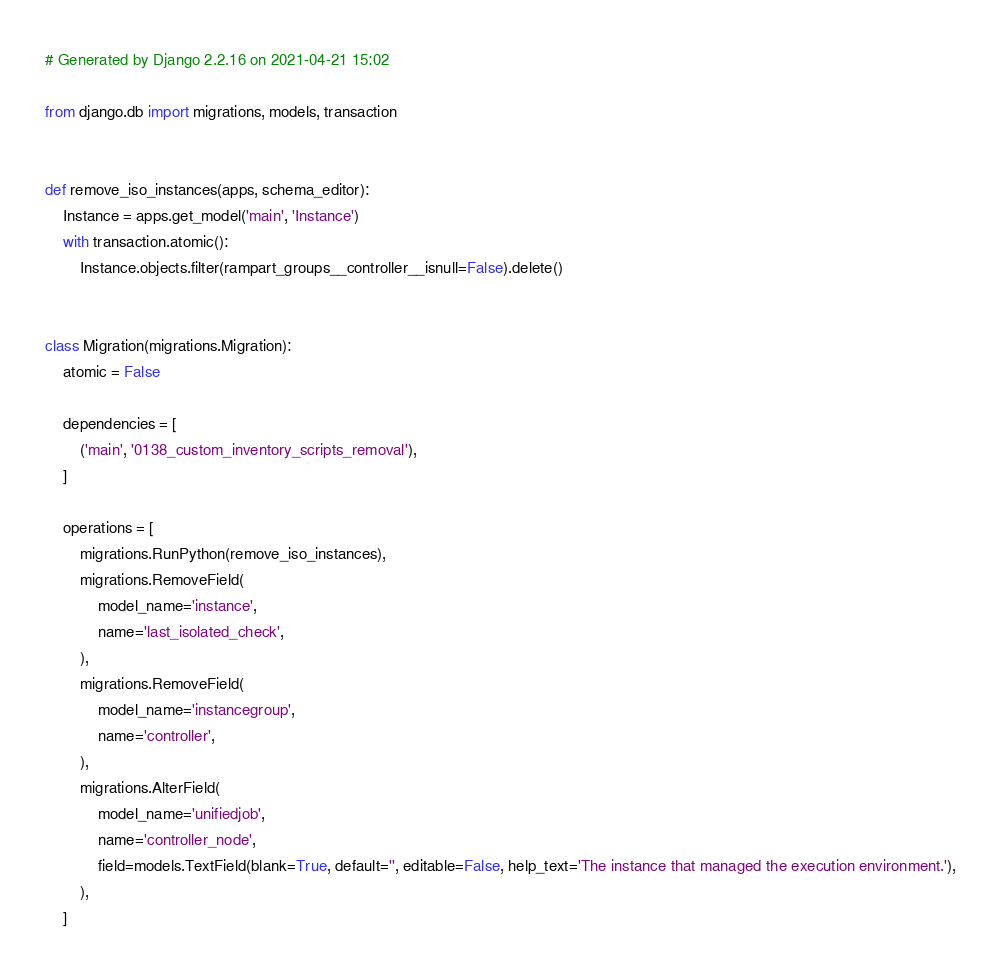<code> <loc_0><loc_0><loc_500><loc_500><_Python_># Generated by Django 2.2.16 on 2021-04-21 15:02

from django.db import migrations, models, transaction


def remove_iso_instances(apps, schema_editor):
    Instance = apps.get_model('main', 'Instance')
    with transaction.atomic():
        Instance.objects.filter(rampart_groups__controller__isnull=False).delete()


class Migration(migrations.Migration):
    atomic = False

    dependencies = [
        ('main', '0138_custom_inventory_scripts_removal'),
    ]

    operations = [
        migrations.RunPython(remove_iso_instances),
        migrations.RemoveField(
            model_name='instance',
            name='last_isolated_check',
        ),
        migrations.RemoveField(
            model_name='instancegroup',
            name='controller',
        ),
        migrations.AlterField(
            model_name='unifiedjob',
            name='controller_node',
            field=models.TextField(blank=True, default='', editable=False, help_text='The instance that managed the execution environment.'),
        ),
    ]
</code> 